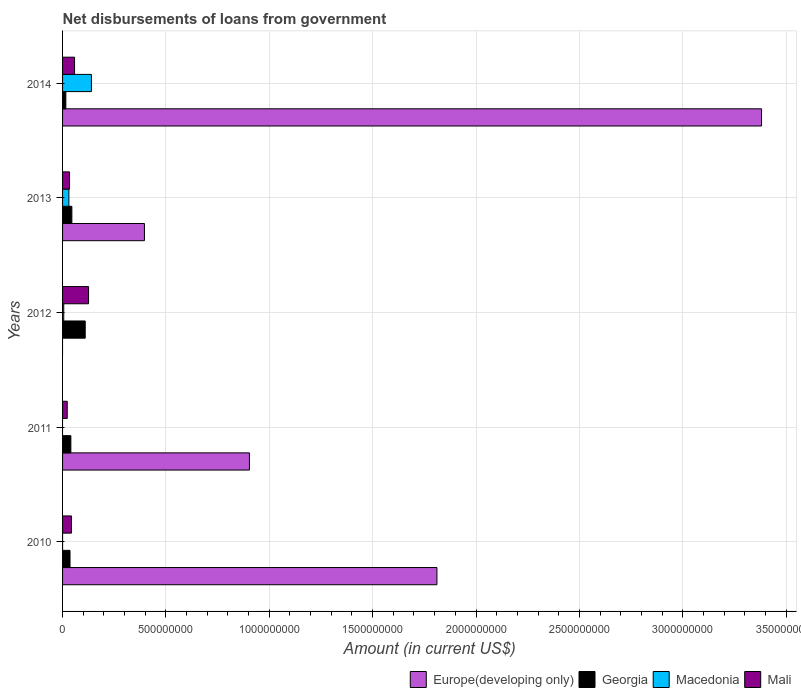How many different coloured bars are there?
Provide a short and direct response. 4. Are the number of bars per tick equal to the number of legend labels?
Your response must be concise. No. What is the label of the 3rd group of bars from the top?
Your answer should be very brief. 2012. What is the amount of loan disbursed from government in Mali in 2014?
Ensure brevity in your answer.  5.80e+07. Across all years, what is the maximum amount of loan disbursed from government in Mali?
Your answer should be very brief. 1.26e+08. Across all years, what is the minimum amount of loan disbursed from government in Georgia?
Provide a short and direct response. 1.58e+07. In which year was the amount of loan disbursed from government in Europe(developing only) maximum?
Your response must be concise. 2014. What is the total amount of loan disbursed from government in Macedonia in the graph?
Make the answer very short. 1.76e+08. What is the difference between the amount of loan disbursed from government in Georgia in 2011 and that in 2014?
Your answer should be compact. 2.43e+07. What is the difference between the amount of loan disbursed from government in Macedonia in 2014 and the amount of loan disbursed from government in Europe(developing only) in 2013?
Provide a succinct answer. -2.57e+08. What is the average amount of loan disbursed from government in Macedonia per year?
Offer a terse response. 3.52e+07. In the year 2014, what is the difference between the amount of loan disbursed from government in Mali and amount of loan disbursed from government in Georgia?
Make the answer very short. 4.22e+07. In how many years, is the amount of loan disbursed from government in Georgia greater than 2100000000 US$?
Keep it short and to the point. 0. What is the ratio of the amount of loan disbursed from government in Europe(developing only) in 2010 to that in 2011?
Ensure brevity in your answer.  2. Is the amount of loan disbursed from government in Mali in 2010 less than that in 2013?
Provide a succinct answer. No. Is the difference between the amount of loan disbursed from government in Mali in 2011 and 2014 greater than the difference between the amount of loan disbursed from government in Georgia in 2011 and 2014?
Give a very brief answer. No. What is the difference between the highest and the second highest amount of loan disbursed from government in Europe(developing only)?
Offer a very short reply. 1.57e+09. What is the difference between the highest and the lowest amount of loan disbursed from government in Europe(developing only)?
Provide a succinct answer. 3.38e+09. Is the sum of the amount of loan disbursed from government in Europe(developing only) in 2010 and 2011 greater than the maximum amount of loan disbursed from government in Georgia across all years?
Give a very brief answer. Yes. Are all the bars in the graph horizontal?
Your answer should be compact. Yes. How many years are there in the graph?
Provide a short and direct response. 5. Does the graph contain any zero values?
Make the answer very short. Yes. Does the graph contain grids?
Offer a very short reply. Yes. How many legend labels are there?
Offer a very short reply. 4. What is the title of the graph?
Your response must be concise. Net disbursements of loans from government. What is the label or title of the X-axis?
Your answer should be very brief. Amount (in current US$). What is the label or title of the Y-axis?
Your response must be concise. Years. What is the Amount (in current US$) in Europe(developing only) in 2010?
Make the answer very short. 1.81e+09. What is the Amount (in current US$) of Georgia in 2010?
Keep it short and to the point. 3.61e+07. What is the Amount (in current US$) of Macedonia in 2010?
Provide a succinct answer. 3000. What is the Amount (in current US$) in Mali in 2010?
Provide a short and direct response. 4.29e+07. What is the Amount (in current US$) of Europe(developing only) in 2011?
Ensure brevity in your answer.  9.04e+08. What is the Amount (in current US$) of Georgia in 2011?
Your answer should be compact. 4.01e+07. What is the Amount (in current US$) in Macedonia in 2011?
Your answer should be compact. 0. What is the Amount (in current US$) in Mali in 2011?
Give a very brief answer. 2.26e+07. What is the Amount (in current US$) of Europe(developing only) in 2012?
Ensure brevity in your answer.  0. What is the Amount (in current US$) in Georgia in 2012?
Keep it short and to the point. 1.10e+08. What is the Amount (in current US$) in Macedonia in 2012?
Your response must be concise. 5.76e+06. What is the Amount (in current US$) of Mali in 2012?
Keep it short and to the point. 1.26e+08. What is the Amount (in current US$) of Europe(developing only) in 2013?
Provide a succinct answer. 3.96e+08. What is the Amount (in current US$) in Georgia in 2013?
Make the answer very short. 4.49e+07. What is the Amount (in current US$) in Macedonia in 2013?
Ensure brevity in your answer.  3.06e+07. What is the Amount (in current US$) in Mali in 2013?
Give a very brief answer. 3.38e+07. What is the Amount (in current US$) of Europe(developing only) in 2014?
Provide a succinct answer. 3.38e+09. What is the Amount (in current US$) of Georgia in 2014?
Give a very brief answer. 1.58e+07. What is the Amount (in current US$) in Macedonia in 2014?
Your response must be concise. 1.40e+08. What is the Amount (in current US$) of Mali in 2014?
Provide a short and direct response. 5.80e+07. Across all years, what is the maximum Amount (in current US$) of Europe(developing only)?
Provide a short and direct response. 3.38e+09. Across all years, what is the maximum Amount (in current US$) of Georgia?
Provide a succinct answer. 1.10e+08. Across all years, what is the maximum Amount (in current US$) of Macedonia?
Provide a succinct answer. 1.40e+08. Across all years, what is the maximum Amount (in current US$) in Mali?
Your response must be concise. 1.26e+08. Across all years, what is the minimum Amount (in current US$) in Europe(developing only)?
Offer a very short reply. 0. Across all years, what is the minimum Amount (in current US$) of Georgia?
Provide a short and direct response. 1.58e+07. Across all years, what is the minimum Amount (in current US$) of Macedonia?
Offer a terse response. 0. Across all years, what is the minimum Amount (in current US$) in Mali?
Ensure brevity in your answer.  2.26e+07. What is the total Amount (in current US$) in Europe(developing only) in the graph?
Provide a succinct answer. 6.49e+09. What is the total Amount (in current US$) in Georgia in the graph?
Ensure brevity in your answer.  2.47e+08. What is the total Amount (in current US$) in Macedonia in the graph?
Your answer should be compact. 1.76e+08. What is the total Amount (in current US$) in Mali in the graph?
Provide a succinct answer. 2.83e+08. What is the difference between the Amount (in current US$) of Europe(developing only) in 2010 and that in 2011?
Provide a succinct answer. 9.07e+08. What is the difference between the Amount (in current US$) in Georgia in 2010 and that in 2011?
Offer a terse response. -4.10e+06. What is the difference between the Amount (in current US$) in Mali in 2010 and that in 2011?
Make the answer very short. 2.03e+07. What is the difference between the Amount (in current US$) of Georgia in 2010 and that in 2012?
Ensure brevity in your answer.  -7.35e+07. What is the difference between the Amount (in current US$) of Macedonia in 2010 and that in 2012?
Your response must be concise. -5.75e+06. What is the difference between the Amount (in current US$) in Mali in 2010 and that in 2012?
Your response must be concise. -8.28e+07. What is the difference between the Amount (in current US$) of Europe(developing only) in 2010 and that in 2013?
Your answer should be compact. 1.41e+09. What is the difference between the Amount (in current US$) in Georgia in 2010 and that in 2013?
Your answer should be compact. -8.88e+06. What is the difference between the Amount (in current US$) of Macedonia in 2010 and that in 2013?
Your response must be concise. -3.06e+07. What is the difference between the Amount (in current US$) in Mali in 2010 and that in 2013?
Provide a short and direct response. 9.09e+06. What is the difference between the Amount (in current US$) in Europe(developing only) in 2010 and that in 2014?
Provide a succinct answer. -1.57e+09. What is the difference between the Amount (in current US$) in Georgia in 2010 and that in 2014?
Keep it short and to the point. 2.02e+07. What is the difference between the Amount (in current US$) of Macedonia in 2010 and that in 2014?
Your response must be concise. -1.40e+08. What is the difference between the Amount (in current US$) in Mali in 2010 and that in 2014?
Offer a terse response. -1.51e+07. What is the difference between the Amount (in current US$) in Georgia in 2011 and that in 2012?
Provide a succinct answer. -6.94e+07. What is the difference between the Amount (in current US$) in Mali in 2011 and that in 2012?
Provide a short and direct response. -1.03e+08. What is the difference between the Amount (in current US$) in Europe(developing only) in 2011 and that in 2013?
Your answer should be compact. 5.08e+08. What is the difference between the Amount (in current US$) of Georgia in 2011 and that in 2013?
Provide a succinct answer. -4.78e+06. What is the difference between the Amount (in current US$) of Mali in 2011 and that in 2013?
Your response must be concise. -1.12e+07. What is the difference between the Amount (in current US$) in Europe(developing only) in 2011 and that in 2014?
Ensure brevity in your answer.  -2.48e+09. What is the difference between the Amount (in current US$) in Georgia in 2011 and that in 2014?
Provide a succinct answer. 2.43e+07. What is the difference between the Amount (in current US$) of Mali in 2011 and that in 2014?
Your response must be concise. -3.55e+07. What is the difference between the Amount (in current US$) of Georgia in 2012 and that in 2013?
Provide a succinct answer. 6.46e+07. What is the difference between the Amount (in current US$) in Macedonia in 2012 and that in 2013?
Give a very brief answer. -2.48e+07. What is the difference between the Amount (in current US$) in Mali in 2012 and that in 2013?
Offer a very short reply. 9.19e+07. What is the difference between the Amount (in current US$) in Georgia in 2012 and that in 2014?
Ensure brevity in your answer.  9.37e+07. What is the difference between the Amount (in current US$) of Macedonia in 2012 and that in 2014?
Keep it short and to the point. -1.34e+08. What is the difference between the Amount (in current US$) of Mali in 2012 and that in 2014?
Give a very brief answer. 6.77e+07. What is the difference between the Amount (in current US$) of Europe(developing only) in 2013 and that in 2014?
Your answer should be compact. -2.99e+09. What is the difference between the Amount (in current US$) of Georgia in 2013 and that in 2014?
Ensure brevity in your answer.  2.91e+07. What is the difference between the Amount (in current US$) in Macedonia in 2013 and that in 2014?
Make the answer very short. -1.09e+08. What is the difference between the Amount (in current US$) of Mali in 2013 and that in 2014?
Provide a short and direct response. -2.42e+07. What is the difference between the Amount (in current US$) of Europe(developing only) in 2010 and the Amount (in current US$) of Georgia in 2011?
Ensure brevity in your answer.  1.77e+09. What is the difference between the Amount (in current US$) in Europe(developing only) in 2010 and the Amount (in current US$) in Mali in 2011?
Provide a short and direct response. 1.79e+09. What is the difference between the Amount (in current US$) in Georgia in 2010 and the Amount (in current US$) in Mali in 2011?
Keep it short and to the point. 1.35e+07. What is the difference between the Amount (in current US$) of Macedonia in 2010 and the Amount (in current US$) of Mali in 2011?
Keep it short and to the point. -2.26e+07. What is the difference between the Amount (in current US$) of Europe(developing only) in 2010 and the Amount (in current US$) of Georgia in 2012?
Your answer should be compact. 1.70e+09. What is the difference between the Amount (in current US$) in Europe(developing only) in 2010 and the Amount (in current US$) in Macedonia in 2012?
Provide a short and direct response. 1.81e+09. What is the difference between the Amount (in current US$) of Europe(developing only) in 2010 and the Amount (in current US$) of Mali in 2012?
Make the answer very short. 1.69e+09. What is the difference between the Amount (in current US$) in Georgia in 2010 and the Amount (in current US$) in Macedonia in 2012?
Your response must be concise. 3.03e+07. What is the difference between the Amount (in current US$) of Georgia in 2010 and the Amount (in current US$) of Mali in 2012?
Your answer should be very brief. -8.97e+07. What is the difference between the Amount (in current US$) of Macedonia in 2010 and the Amount (in current US$) of Mali in 2012?
Ensure brevity in your answer.  -1.26e+08. What is the difference between the Amount (in current US$) in Europe(developing only) in 2010 and the Amount (in current US$) in Georgia in 2013?
Give a very brief answer. 1.77e+09. What is the difference between the Amount (in current US$) in Europe(developing only) in 2010 and the Amount (in current US$) in Macedonia in 2013?
Provide a short and direct response. 1.78e+09. What is the difference between the Amount (in current US$) of Europe(developing only) in 2010 and the Amount (in current US$) of Mali in 2013?
Your answer should be very brief. 1.78e+09. What is the difference between the Amount (in current US$) in Georgia in 2010 and the Amount (in current US$) in Macedonia in 2013?
Make the answer very short. 5.49e+06. What is the difference between the Amount (in current US$) of Georgia in 2010 and the Amount (in current US$) of Mali in 2013?
Your response must be concise. 2.23e+06. What is the difference between the Amount (in current US$) of Macedonia in 2010 and the Amount (in current US$) of Mali in 2013?
Ensure brevity in your answer.  -3.38e+07. What is the difference between the Amount (in current US$) in Europe(developing only) in 2010 and the Amount (in current US$) in Georgia in 2014?
Make the answer very short. 1.80e+09. What is the difference between the Amount (in current US$) in Europe(developing only) in 2010 and the Amount (in current US$) in Macedonia in 2014?
Your answer should be very brief. 1.67e+09. What is the difference between the Amount (in current US$) of Europe(developing only) in 2010 and the Amount (in current US$) of Mali in 2014?
Your response must be concise. 1.75e+09. What is the difference between the Amount (in current US$) of Georgia in 2010 and the Amount (in current US$) of Macedonia in 2014?
Make the answer very short. -1.04e+08. What is the difference between the Amount (in current US$) in Georgia in 2010 and the Amount (in current US$) in Mali in 2014?
Your answer should be very brief. -2.20e+07. What is the difference between the Amount (in current US$) of Macedonia in 2010 and the Amount (in current US$) of Mali in 2014?
Your answer should be compact. -5.80e+07. What is the difference between the Amount (in current US$) of Europe(developing only) in 2011 and the Amount (in current US$) of Georgia in 2012?
Ensure brevity in your answer.  7.94e+08. What is the difference between the Amount (in current US$) of Europe(developing only) in 2011 and the Amount (in current US$) of Macedonia in 2012?
Ensure brevity in your answer.  8.98e+08. What is the difference between the Amount (in current US$) in Europe(developing only) in 2011 and the Amount (in current US$) in Mali in 2012?
Offer a very short reply. 7.78e+08. What is the difference between the Amount (in current US$) of Georgia in 2011 and the Amount (in current US$) of Macedonia in 2012?
Offer a terse response. 3.44e+07. What is the difference between the Amount (in current US$) of Georgia in 2011 and the Amount (in current US$) of Mali in 2012?
Your answer should be compact. -8.56e+07. What is the difference between the Amount (in current US$) of Europe(developing only) in 2011 and the Amount (in current US$) of Georgia in 2013?
Your answer should be compact. 8.59e+08. What is the difference between the Amount (in current US$) of Europe(developing only) in 2011 and the Amount (in current US$) of Macedonia in 2013?
Provide a short and direct response. 8.73e+08. What is the difference between the Amount (in current US$) of Europe(developing only) in 2011 and the Amount (in current US$) of Mali in 2013?
Your answer should be very brief. 8.70e+08. What is the difference between the Amount (in current US$) in Georgia in 2011 and the Amount (in current US$) in Macedonia in 2013?
Offer a terse response. 9.59e+06. What is the difference between the Amount (in current US$) of Georgia in 2011 and the Amount (in current US$) of Mali in 2013?
Ensure brevity in your answer.  6.33e+06. What is the difference between the Amount (in current US$) of Europe(developing only) in 2011 and the Amount (in current US$) of Georgia in 2014?
Provide a short and direct response. 8.88e+08. What is the difference between the Amount (in current US$) in Europe(developing only) in 2011 and the Amount (in current US$) in Macedonia in 2014?
Make the answer very short. 7.64e+08. What is the difference between the Amount (in current US$) of Europe(developing only) in 2011 and the Amount (in current US$) of Mali in 2014?
Provide a succinct answer. 8.46e+08. What is the difference between the Amount (in current US$) of Georgia in 2011 and the Amount (in current US$) of Macedonia in 2014?
Ensure brevity in your answer.  -9.94e+07. What is the difference between the Amount (in current US$) in Georgia in 2011 and the Amount (in current US$) in Mali in 2014?
Provide a short and direct response. -1.79e+07. What is the difference between the Amount (in current US$) of Georgia in 2012 and the Amount (in current US$) of Macedonia in 2013?
Ensure brevity in your answer.  7.90e+07. What is the difference between the Amount (in current US$) of Georgia in 2012 and the Amount (in current US$) of Mali in 2013?
Your response must be concise. 7.57e+07. What is the difference between the Amount (in current US$) in Macedonia in 2012 and the Amount (in current US$) in Mali in 2013?
Ensure brevity in your answer.  -2.81e+07. What is the difference between the Amount (in current US$) of Georgia in 2012 and the Amount (in current US$) of Macedonia in 2014?
Offer a very short reply. -3.00e+07. What is the difference between the Amount (in current US$) of Georgia in 2012 and the Amount (in current US$) of Mali in 2014?
Keep it short and to the point. 5.15e+07. What is the difference between the Amount (in current US$) of Macedonia in 2012 and the Amount (in current US$) of Mali in 2014?
Your answer should be very brief. -5.23e+07. What is the difference between the Amount (in current US$) of Europe(developing only) in 2013 and the Amount (in current US$) of Georgia in 2014?
Offer a terse response. 3.80e+08. What is the difference between the Amount (in current US$) in Europe(developing only) in 2013 and the Amount (in current US$) in Macedonia in 2014?
Your answer should be very brief. 2.57e+08. What is the difference between the Amount (in current US$) in Europe(developing only) in 2013 and the Amount (in current US$) in Mali in 2014?
Your response must be concise. 3.38e+08. What is the difference between the Amount (in current US$) in Georgia in 2013 and the Amount (in current US$) in Macedonia in 2014?
Offer a terse response. -9.46e+07. What is the difference between the Amount (in current US$) of Georgia in 2013 and the Amount (in current US$) of Mali in 2014?
Your answer should be compact. -1.31e+07. What is the difference between the Amount (in current US$) in Macedonia in 2013 and the Amount (in current US$) in Mali in 2014?
Your answer should be compact. -2.75e+07. What is the average Amount (in current US$) of Europe(developing only) per year?
Offer a terse response. 1.30e+09. What is the average Amount (in current US$) in Georgia per year?
Your answer should be very brief. 4.93e+07. What is the average Amount (in current US$) in Macedonia per year?
Ensure brevity in your answer.  3.52e+07. What is the average Amount (in current US$) of Mali per year?
Provide a succinct answer. 5.66e+07. In the year 2010, what is the difference between the Amount (in current US$) of Europe(developing only) and Amount (in current US$) of Georgia?
Your answer should be compact. 1.77e+09. In the year 2010, what is the difference between the Amount (in current US$) of Europe(developing only) and Amount (in current US$) of Macedonia?
Ensure brevity in your answer.  1.81e+09. In the year 2010, what is the difference between the Amount (in current US$) in Europe(developing only) and Amount (in current US$) in Mali?
Offer a terse response. 1.77e+09. In the year 2010, what is the difference between the Amount (in current US$) of Georgia and Amount (in current US$) of Macedonia?
Ensure brevity in your answer.  3.60e+07. In the year 2010, what is the difference between the Amount (in current US$) of Georgia and Amount (in current US$) of Mali?
Keep it short and to the point. -6.86e+06. In the year 2010, what is the difference between the Amount (in current US$) in Macedonia and Amount (in current US$) in Mali?
Keep it short and to the point. -4.29e+07. In the year 2011, what is the difference between the Amount (in current US$) in Europe(developing only) and Amount (in current US$) in Georgia?
Ensure brevity in your answer.  8.64e+08. In the year 2011, what is the difference between the Amount (in current US$) of Europe(developing only) and Amount (in current US$) of Mali?
Provide a succinct answer. 8.81e+08. In the year 2011, what is the difference between the Amount (in current US$) in Georgia and Amount (in current US$) in Mali?
Offer a terse response. 1.76e+07. In the year 2012, what is the difference between the Amount (in current US$) of Georgia and Amount (in current US$) of Macedonia?
Offer a terse response. 1.04e+08. In the year 2012, what is the difference between the Amount (in current US$) of Georgia and Amount (in current US$) of Mali?
Offer a terse response. -1.62e+07. In the year 2012, what is the difference between the Amount (in current US$) of Macedonia and Amount (in current US$) of Mali?
Provide a short and direct response. -1.20e+08. In the year 2013, what is the difference between the Amount (in current US$) of Europe(developing only) and Amount (in current US$) of Georgia?
Make the answer very short. 3.51e+08. In the year 2013, what is the difference between the Amount (in current US$) of Europe(developing only) and Amount (in current US$) of Macedonia?
Keep it short and to the point. 3.66e+08. In the year 2013, what is the difference between the Amount (in current US$) of Europe(developing only) and Amount (in current US$) of Mali?
Your answer should be compact. 3.62e+08. In the year 2013, what is the difference between the Amount (in current US$) in Georgia and Amount (in current US$) in Macedonia?
Ensure brevity in your answer.  1.44e+07. In the year 2013, what is the difference between the Amount (in current US$) of Georgia and Amount (in current US$) of Mali?
Keep it short and to the point. 1.11e+07. In the year 2013, what is the difference between the Amount (in current US$) in Macedonia and Amount (in current US$) in Mali?
Offer a very short reply. -3.26e+06. In the year 2014, what is the difference between the Amount (in current US$) in Europe(developing only) and Amount (in current US$) in Georgia?
Offer a very short reply. 3.37e+09. In the year 2014, what is the difference between the Amount (in current US$) of Europe(developing only) and Amount (in current US$) of Macedonia?
Provide a succinct answer. 3.24e+09. In the year 2014, what is the difference between the Amount (in current US$) of Europe(developing only) and Amount (in current US$) of Mali?
Your response must be concise. 3.32e+09. In the year 2014, what is the difference between the Amount (in current US$) of Georgia and Amount (in current US$) of Macedonia?
Provide a short and direct response. -1.24e+08. In the year 2014, what is the difference between the Amount (in current US$) of Georgia and Amount (in current US$) of Mali?
Give a very brief answer. -4.22e+07. In the year 2014, what is the difference between the Amount (in current US$) of Macedonia and Amount (in current US$) of Mali?
Your response must be concise. 8.15e+07. What is the ratio of the Amount (in current US$) in Europe(developing only) in 2010 to that in 2011?
Give a very brief answer. 2. What is the ratio of the Amount (in current US$) of Georgia in 2010 to that in 2011?
Give a very brief answer. 0.9. What is the ratio of the Amount (in current US$) of Mali in 2010 to that in 2011?
Your answer should be very brief. 1.9. What is the ratio of the Amount (in current US$) of Georgia in 2010 to that in 2012?
Give a very brief answer. 0.33. What is the ratio of the Amount (in current US$) in Mali in 2010 to that in 2012?
Provide a succinct answer. 0.34. What is the ratio of the Amount (in current US$) of Europe(developing only) in 2010 to that in 2013?
Offer a terse response. 4.57. What is the ratio of the Amount (in current US$) of Georgia in 2010 to that in 2013?
Provide a succinct answer. 0.8. What is the ratio of the Amount (in current US$) in Macedonia in 2010 to that in 2013?
Ensure brevity in your answer.  0. What is the ratio of the Amount (in current US$) of Mali in 2010 to that in 2013?
Keep it short and to the point. 1.27. What is the ratio of the Amount (in current US$) of Europe(developing only) in 2010 to that in 2014?
Offer a terse response. 0.54. What is the ratio of the Amount (in current US$) of Georgia in 2010 to that in 2014?
Ensure brevity in your answer.  2.28. What is the ratio of the Amount (in current US$) of Macedonia in 2010 to that in 2014?
Keep it short and to the point. 0. What is the ratio of the Amount (in current US$) of Mali in 2010 to that in 2014?
Your response must be concise. 0.74. What is the ratio of the Amount (in current US$) of Georgia in 2011 to that in 2012?
Provide a succinct answer. 0.37. What is the ratio of the Amount (in current US$) of Mali in 2011 to that in 2012?
Make the answer very short. 0.18. What is the ratio of the Amount (in current US$) in Europe(developing only) in 2011 to that in 2013?
Provide a succinct answer. 2.28. What is the ratio of the Amount (in current US$) in Georgia in 2011 to that in 2013?
Your answer should be very brief. 0.89. What is the ratio of the Amount (in current US$) of Mali in 2011 to that in 2013?
Give a very brief answer. 0.67. What is the ratio of the Amount (in current US$) of Europe(developing only) in 2011 to that in 2014?
Provide a succinct answer. 0.27. What is the ratio of the Amount (in current US$) in Georgia in 2011 to that in 2014?
Offer a very short reply. 2.53. What is the ratio of the Amount (in current US$) in Mali in 2011 to that in 2014?
Your answer should be compact. 0.39. What is the ratio of the Amount (in current US$) in Georgia in 2012 to that in 2013?
Offer a terse response. 2.44. What is the ratio of the Amount (in current US$) in Macedonia in 2012 to that in 2013?
Give a very brief answer. 0.19. What is the ratio of the Amount (in current US$) in Mali in 2012 to that in 2013?
Offer a very short reply. 3.72. What is the ratio of the Amount (in current US$) of Georgia in 2012 to that in 2014?
Your answer should be compact. 6.92. What is the ratio of the Amount (in current US$) of Macedonia in 2012 to that in 2014?
Ensure brevity in your answer.  0.04. What is the ratio of the Amount (in current US$) in Mali in 2012 to that in 2014?
Ensure brevity in your answer.  2.17. What is the ratio of the Amount (in current US$) of Europe(developing only) in 2013 to that in 2014?
Make the answer very short. 0.12. What is the ratio of the Amount (in current US$) of Georgia in 2013 to that in 2014?
Provide a succinct answer. 2.84. What is the ratio of the Amount (in current US$) of Macedonia in 2013 to that in 2014?
Provide a succinct answer. 0.22. What is the ratio of the Amount (in current US$) in Mali in 2013 to that in 2014?
Offer a very short reply. 0.58. What is the difference between the highest and the second highest Amount (in current US$) in Europe(developing only)?
Keep it short and to the point. 1.57e+09. What is the difference between the highest and the second highest Amount (in current US$) in Georgia?
Keep it short and to the point. 6.46e+07. What is the difference between the highest and the second highest Amount (in current US$) of Macedonia?
Ensure brevity in your answer.  1.09e+08. What is the difference between the highest and the second highest Amount (in current US$) in Mali?
Offer a very short reply. 6.77e+07. What is the difference between the highest and the lowest Amount (in current US$) of Europe(developing only)?
Give a very brief answer. 3.38e+09. What is the difference between the highest and the lowest Amount (in current US$) of Georgia?
Your response must be concise. 9.37e+07. What is the difference between the highest and the lowest Amount (in current US$) of Macedonia?
Keep it short and to the point. 1.40e+08. What is the difference between the highest and the lowest Amount (in current US$) of Mali?
Keep it short and to the point. 1.03e+08. 